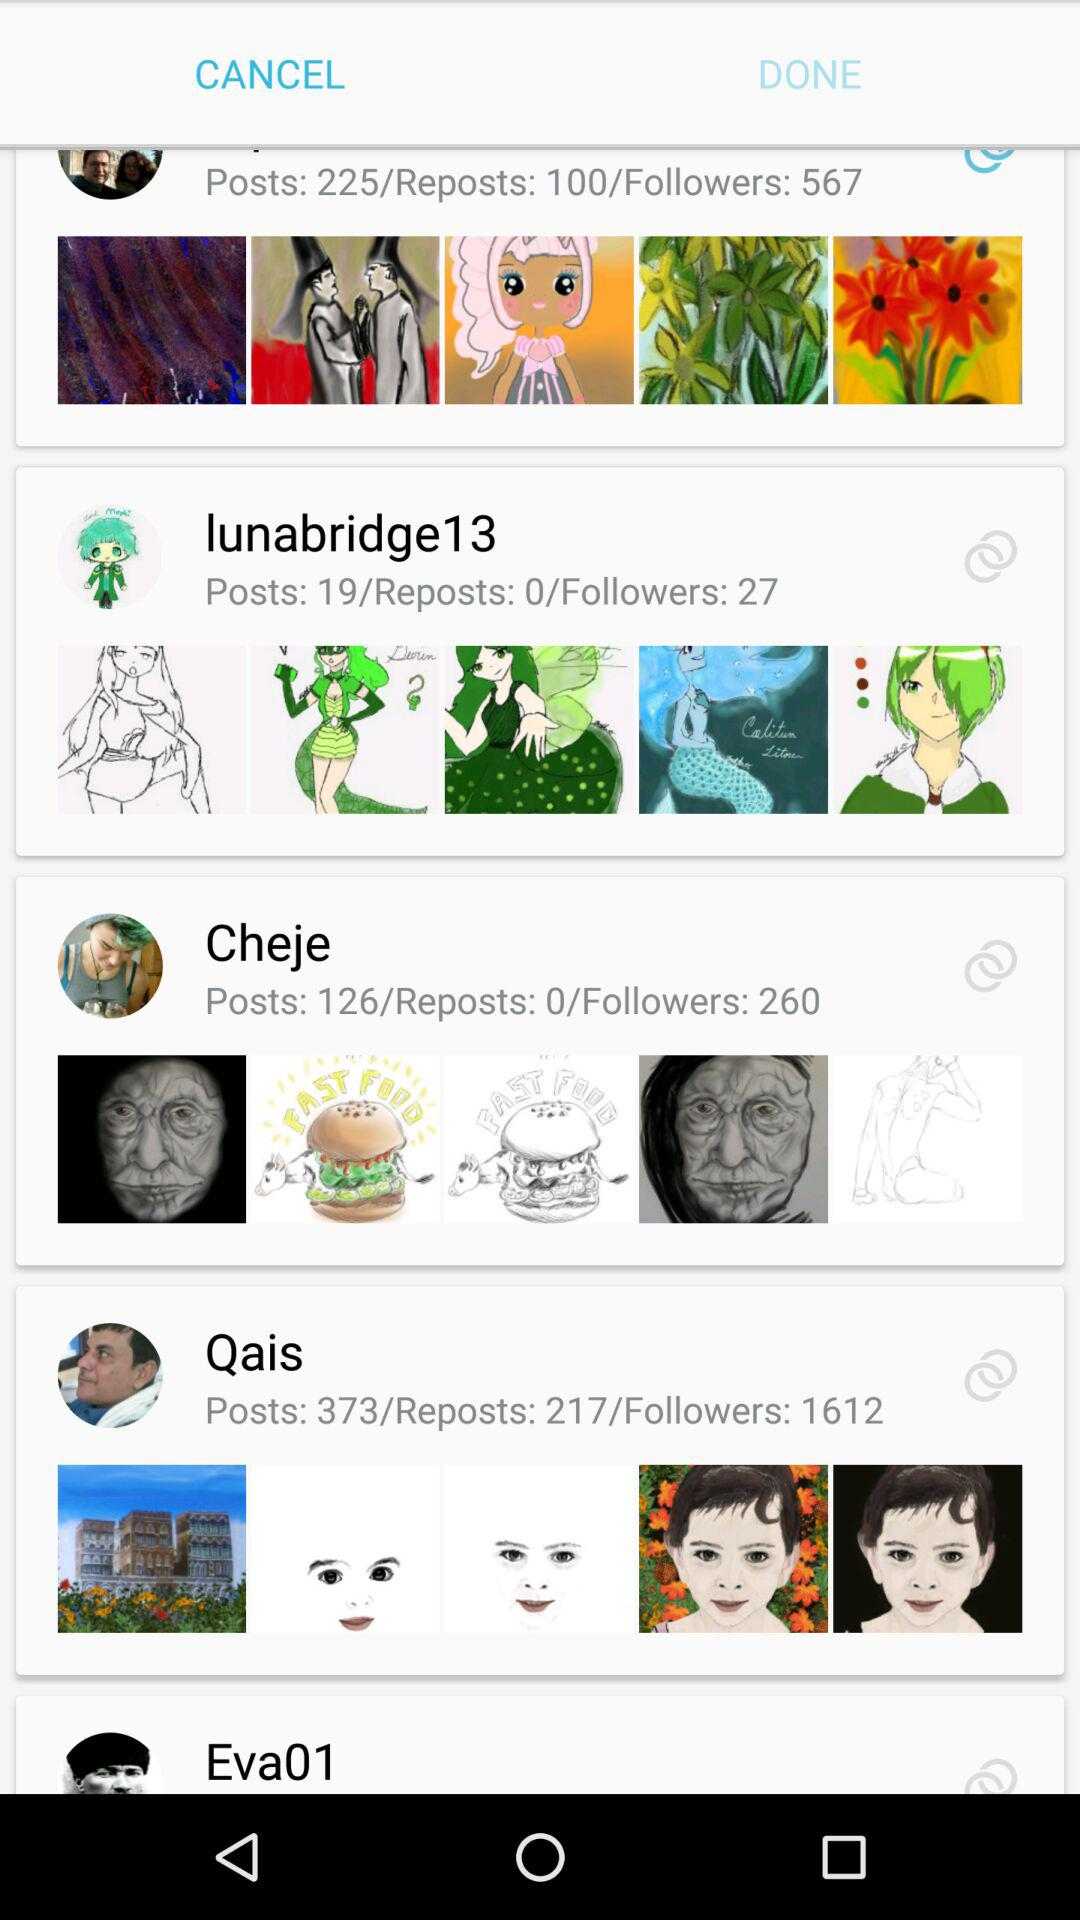How many followers has Lunabridge13 got? "lunabridge13" has got 27 followers. 